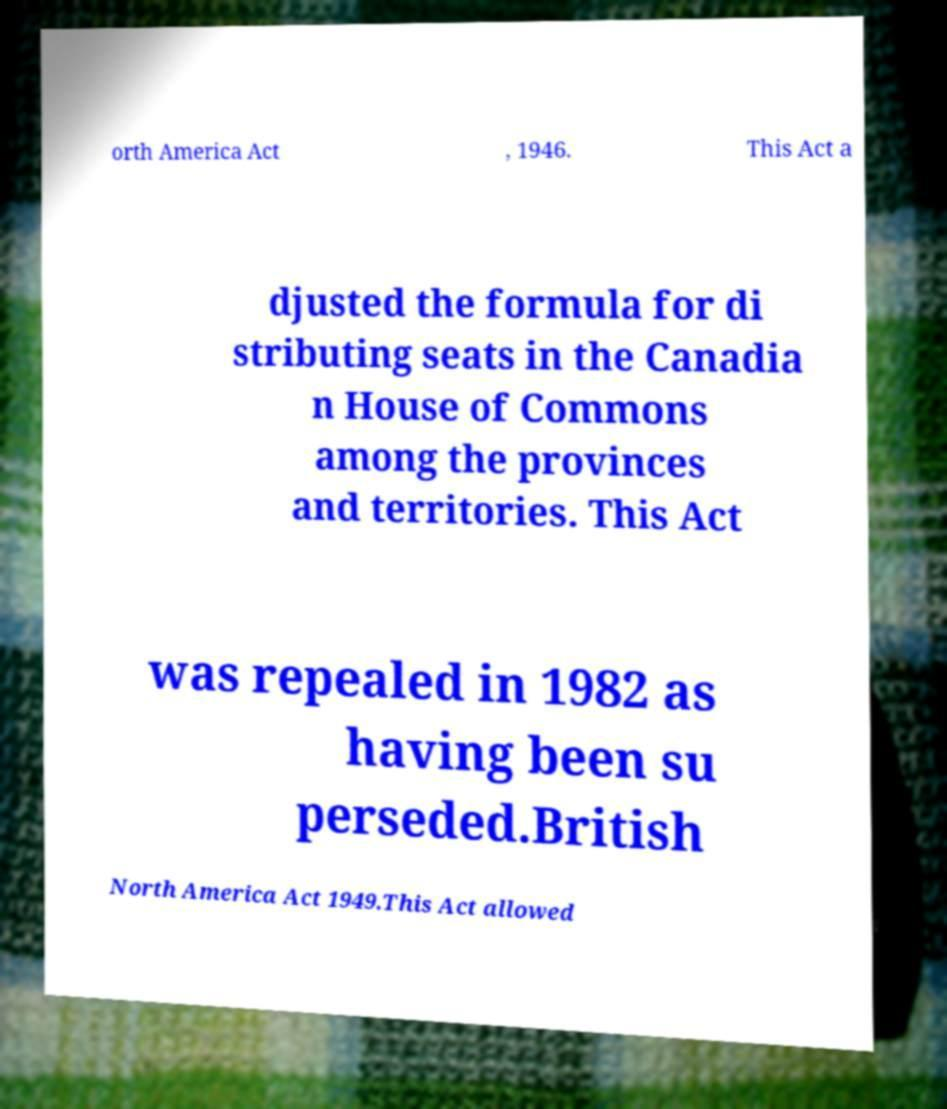Can you read and provide the text displayed in the image?This photo seems to have some interesting text. Can you extract and type it out for me? orth America Act , 1946. This Act a djusted the formula for di stributing seats in the Canadia n House of Commons among the provinces and territories. This Act was repealed in 1982 as having been su perseded.British North America Act 1949.This Act allowed 